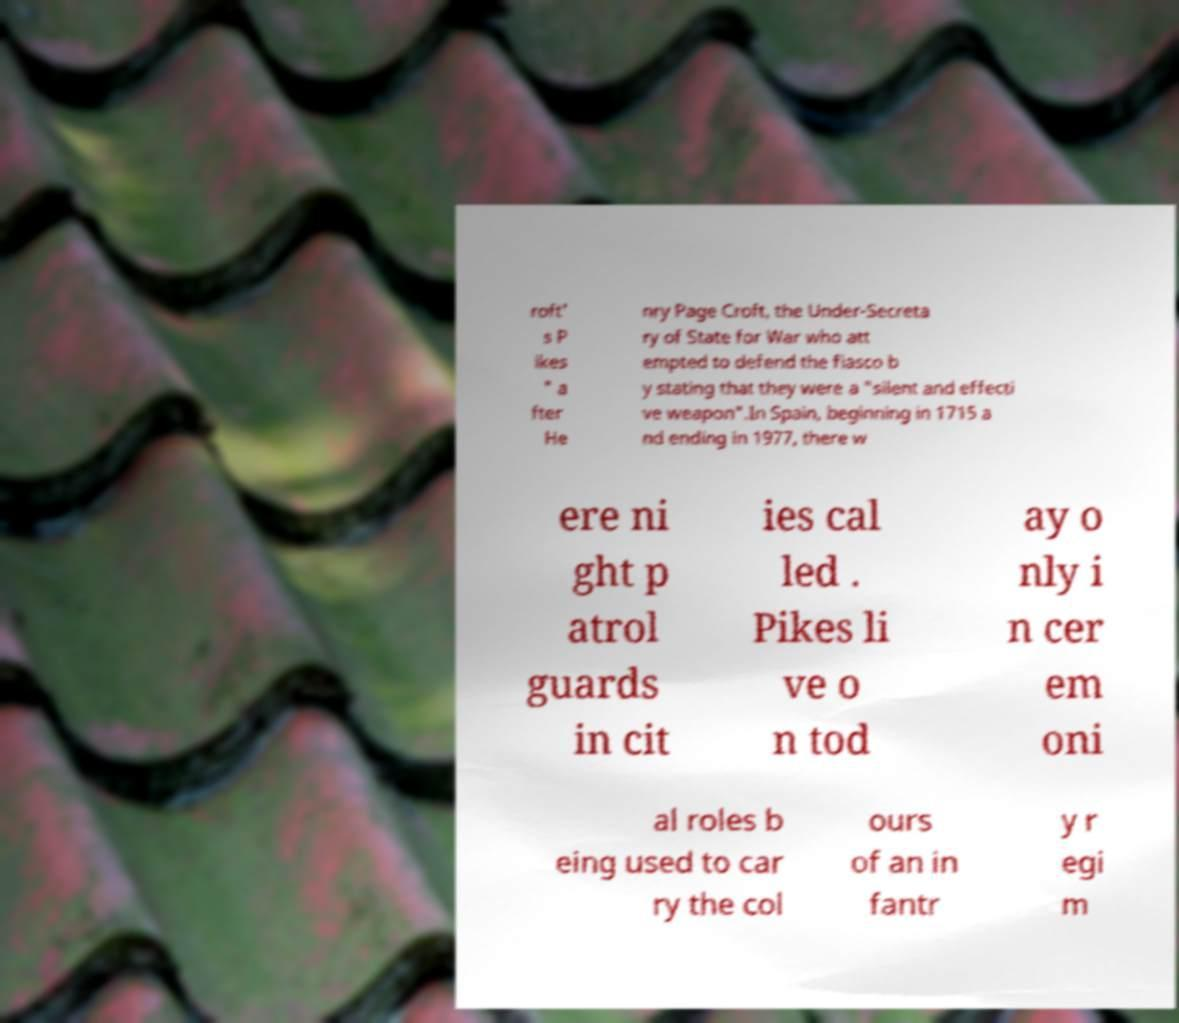I need the written content from this picture converted into text. Can you do that? roft' s P ikes " a fter He nry Page Croft, the Under-Secreta ry of State for War who att empted to defend the fiasco b y stating that they were a "silent and effecti ve weapon".In Spain, beginning in 1715 a nd ending in 1977, there w ere ni ght p atrol guards in cit ies cal led . Pikes li ve o n tod ay o nly i n cer em oni al roles b eing used to car ry the col ours of an in fantr y r egi m 